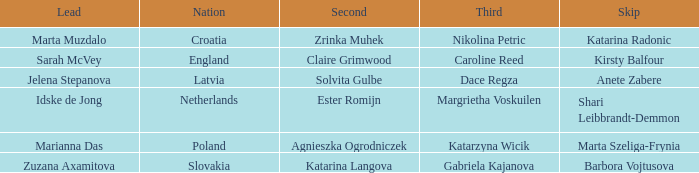Would you mind parsing the complete table? {'header': ['Lead', 'Nation', 'Second', 'Third', 'Skip'], 'rows': [['Marta Muzdalo', 'Croatia', 'Zrinka Muhek', 'Nikolina Petric', 'Katarina Radonic'], ['Sarah McVey', 'England', 'Claire Grimwood', 'Caroline Reed', 'Kirsty Balfour'], ['Jelena Stepanova', 'Latvia', 'Solvita Gulbe', 'Dace Regza', 'Anete Zabere'], ['Idske de Jong', 'Netherlands', 'Ester Romijn', 'Margrietha Voskuilen', 'Shari Leibbrandt-Demmon'], ['Marianna Das', 'Poland', 'Agnieszka Ogrodniczek', 'Katarzyna Wicik', 'Marta Szeliga-Frynia'], ['Zuzana Axamitova', 'Slovakia', 'Katarina Langova', 'Gabriela Kajanova', 'Barbora Vojtusova']]} What is the name of the second who has Caroline Reed as third? Claire Grimwood. 